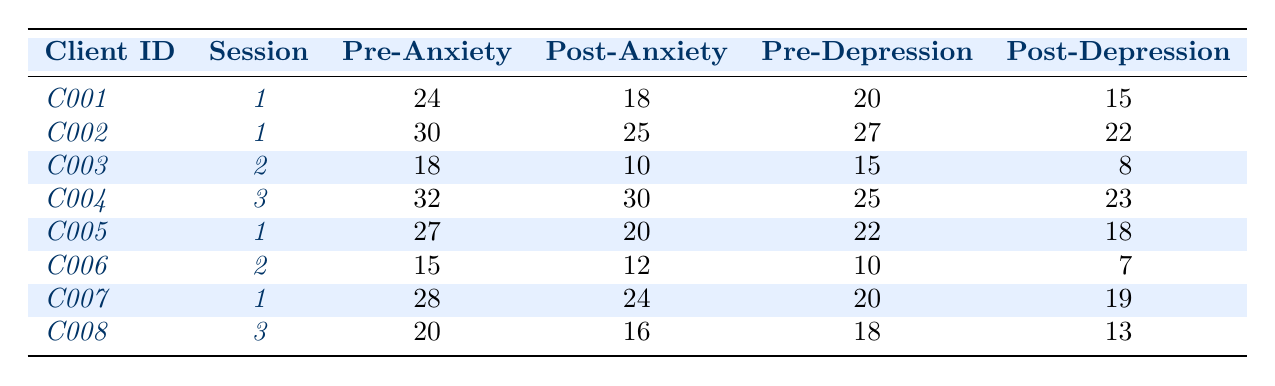What was the post-therapy anxiety score for client C001? Referring to the row for client C001, the post-therapy anxiety score is listed as 18.
Answer: 18 What is the pre-therapy depression score for client C005? Looking at client C005’s row in the table, the pre-therapy depression score is 22.
Answer: 22 Which client had the highest pre-therapy anxiety score? By comparing the pre-therapy anxiety scores, client C004 has the highest score of 32.
Answer: C004 What was the change in anxiety score for client C003? The pre-therapy anxiety score for C003 is 18 and the post-therapy score is 10. The change is calculated as 18 - 10 = 8.
Answer: 8 Did client C007 experience a decrease in depression score after therapy? For client C007, the pre-therapy depression score is 20 and the post-therapy score is 19, indicating a decrease.
Answer: Yes What was the average post-therapy anxiety score across all clients? Summing the post-therapy anxiety scores (18 + 25 + 10 + 30 + 20 + 12 + 24 + 16) gives 155. There are 8 clients, so the average is 155/8 = 19.375.
Answer: 19.375 How many clients had a post-therapy anxiety score lower than 20? Looking at the post-therapy anxiety scores, clients C003 (10), C005 (20), C007 (24), and C008 (16) had scores below 20, totaling 3 clients.
Answer: 3 What is the difference in pre-therapy and post-therapy depression scores for client C006? The pre-therapy depression score for C006 is 10 and the post-therapy score is 7. The difference is 10 - 7 = 3.
Answer: 3 Which client had the largest decrease in depression score after therapy? By analyzing the changes in depression scores, client C003 had a decrease from 15 to 8, which is a change of 7, the largest among all clients.
Answer: C003 For client C002, was the decrease in anxiety score greater than the decrease in depression score? The anxiety score for C002 decreased from 30 to 25 (a change of 5) and the depression score from 27 to 22 (a change of 5). Hence, the decreases are equal.
Answer: No 